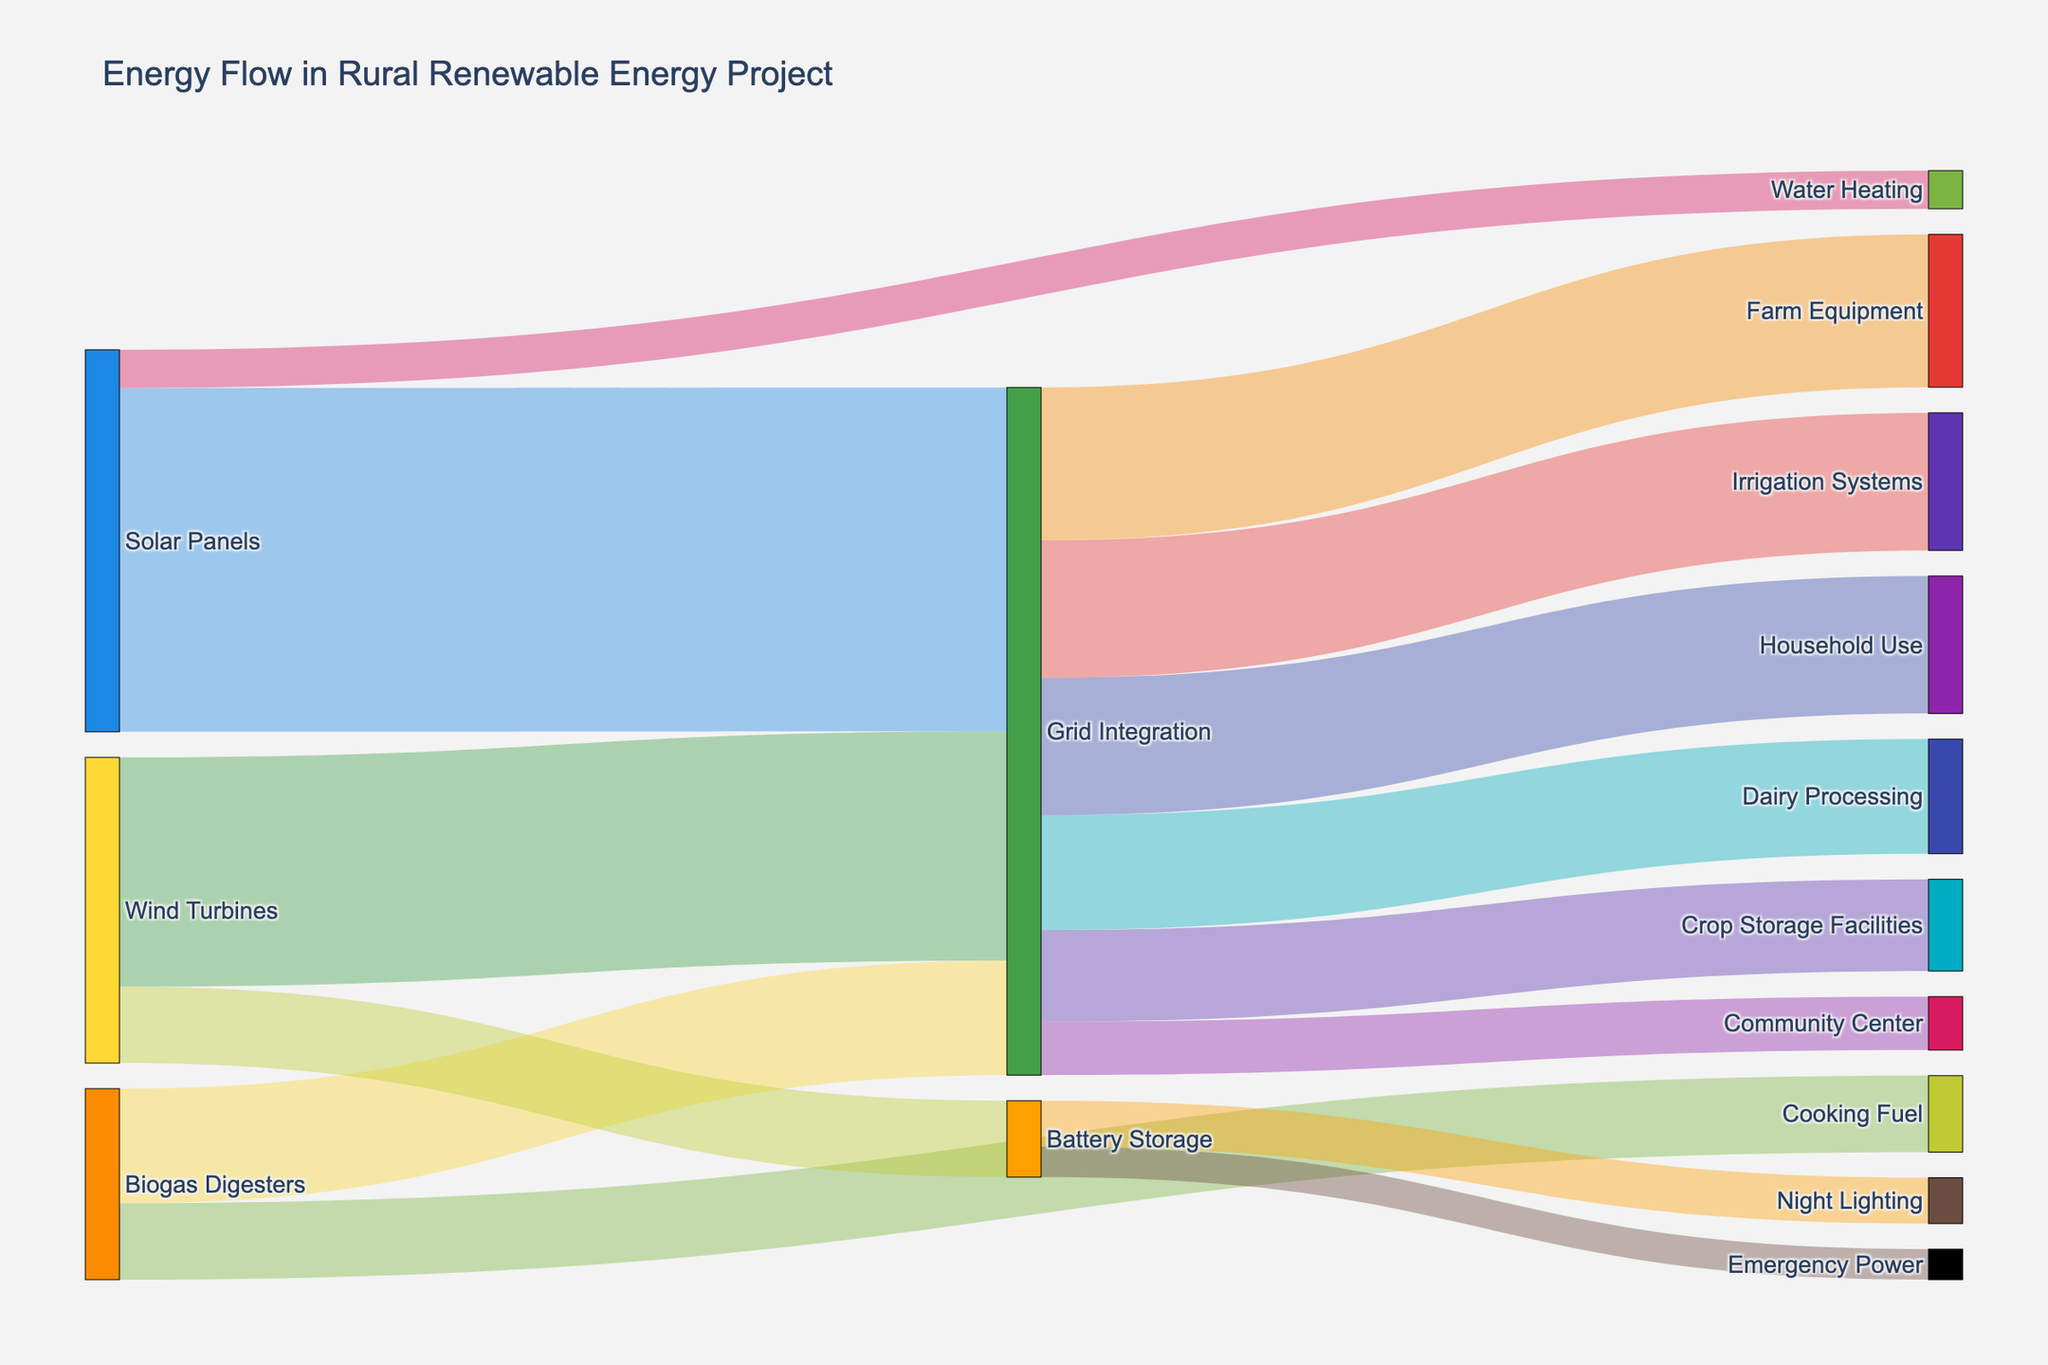What is the total amount of energy provided by Solar Panels to Grid Integration? The Solar Panels contribute a value of 450 units to Grid Integration, as indicated by the figure.
Answer: 450 units Which renewable energy source contributes the least to Grid Integration? The figure shows three renewable energy sources contributing to Grid Integration: Solar Panels (450 units), Wind Turbines (300 units), and Biogas Digesters (150 units). Biogas Digesters contribute the least.
Answer: Biogas Digesters How much energy is allocated from Grid Integration to Dairy Processing? From the figure, we can see that 150 units of energy flow from Grid Integration to Dairy Processing.
Answer: 150 units Compare the energy used by Household Use and Crop Storage Facilities from the Grid Integration. Which uses more? Household Use utilizes 180 units, whereas Crop Storage Facilities utilize 120 units from Grid Integration. Household Use uses more.
Answer: Household Use What is the total amount of energy utilized by Farm Equipment and Irrigation Systems combined? Farm Equipment uses 200 units and Irrigation Systems use 180 units. Combined, they utilize 200 + 180 = 380 units.
Answer: 380 units Out of the energies flowing from Grid Integration, which sector uses the least amount of energy, and how much is it? The energy amounts flowing from Grid Integration are: Farm Equipment (200 units), Irrigation Systems (180 units), Crop Storage Facilities (120 units), Dairy Processing (150 units), Household Use (180 units), Community Center (70 units). The least energy is used by the Community Center.
Answer: Community Center, 70 units What is the sum of the energy values flowing into Battery Storage? Wind Turbines contribute 100 units to Battery Storage, so the total energy value is 100 units.
Answer: 100 units How much energy, in total, does the figure show being used for Cooking Fuel? From the figure, Biogas Digesters contribute 100 units directly to Cooking Fuel.
Answer: 100 units Compare the energy provided by Solar Panels for Water Heating with the energy provided by Biogas Digesters for Cooking Fuel. Which is higher? The figure shows Solar Panels providing 50 units for Water Heating and Biogas Digesters providing 100 units for Cooking Fuel. Cooking Fuel receives more energy.
Answer: Cooking Fuel What is the total energy flow from renewable sources to Grid Integration? Adding the contributions from Solar Panels (450 units), Wind Turbines (300 units), and Biogas Digesters (150 units) gives 450 + 300 + 150 = 900 units.
Answer: 900 units 